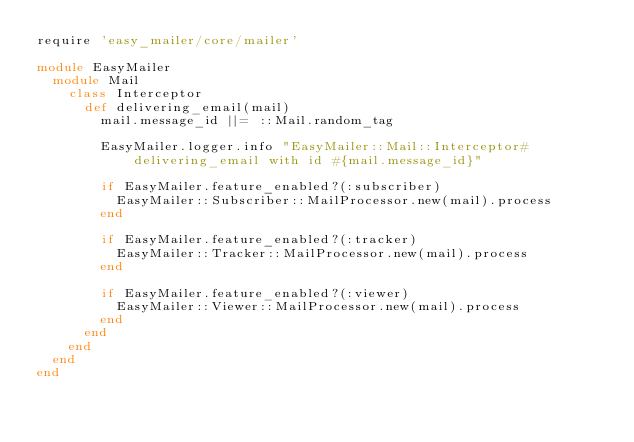<code> <loc_0><loc_0><loc_500><loc_500><_Ruby_>require 'easy_mailer/core/mailer'

module EasyMailer
  module Mail
    class Interceptor
      def delivering_email(mail)
        mail.message_id ||= ::Mail.random_tag

        EasyMailer.logger.info "EasyMailer::Mail::Interceptor#delivering_email with id #{mail.message_id}"

        if EasyMailer.feature_enabled?(:subscriber)
          EasyMailer::Subscriber::MailProcessor.new(mail).process
        end

        if EasyMailer.feature_enabled?(:tracker)
          EasyMailer::Tracker::MailProcessor.new(mail).process
        end

        if EasyMailer.feature_enabled?(:viewer)
          EasyMailer::Viewer::MailProcessor.new(mail).process
        end
      end
    end
  end
end</code> 